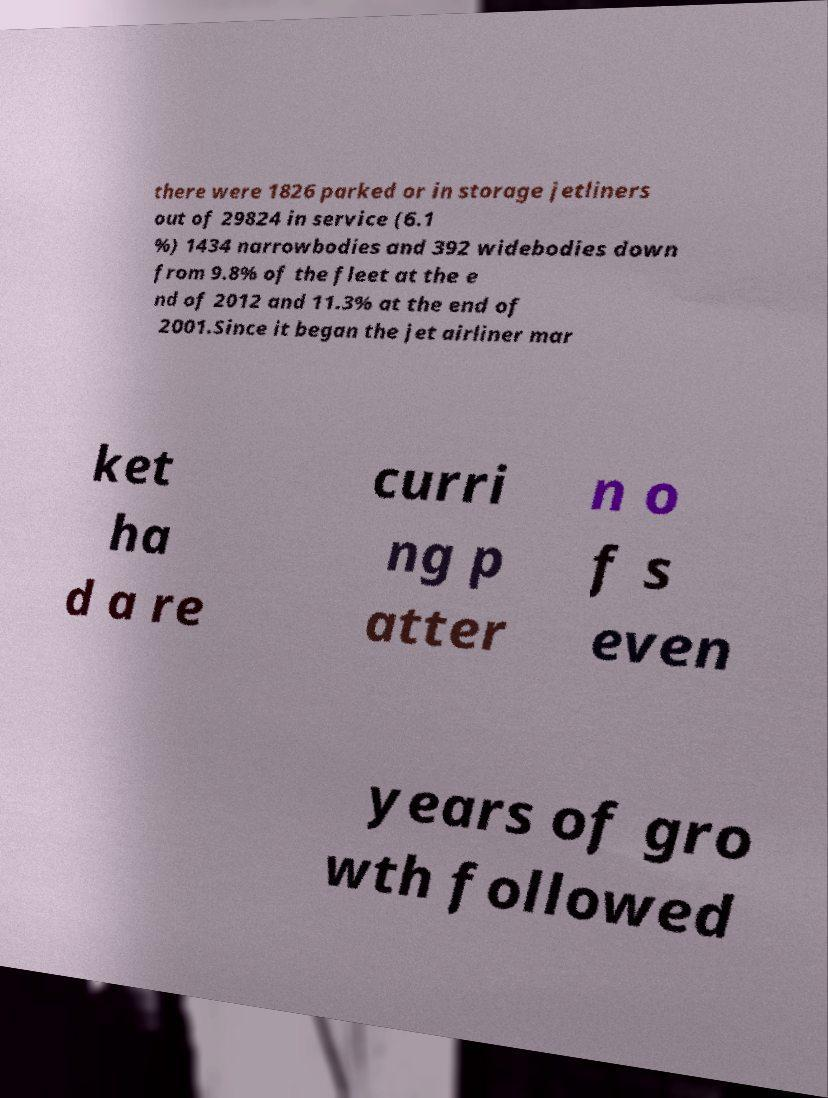Could you extract and type out the text from this image? there were 1826 parked or in storage jetliners out of 29824 in service (6.1 %) 1434 narrowbodies and 392 widebodies down from 9.8% of the fleet at the e nd of 2012 and 11.3% at the end of 2001.Since it began the jet airliner mar ket ha d a re curri ng p atter n o f s even years of gro wth followed 